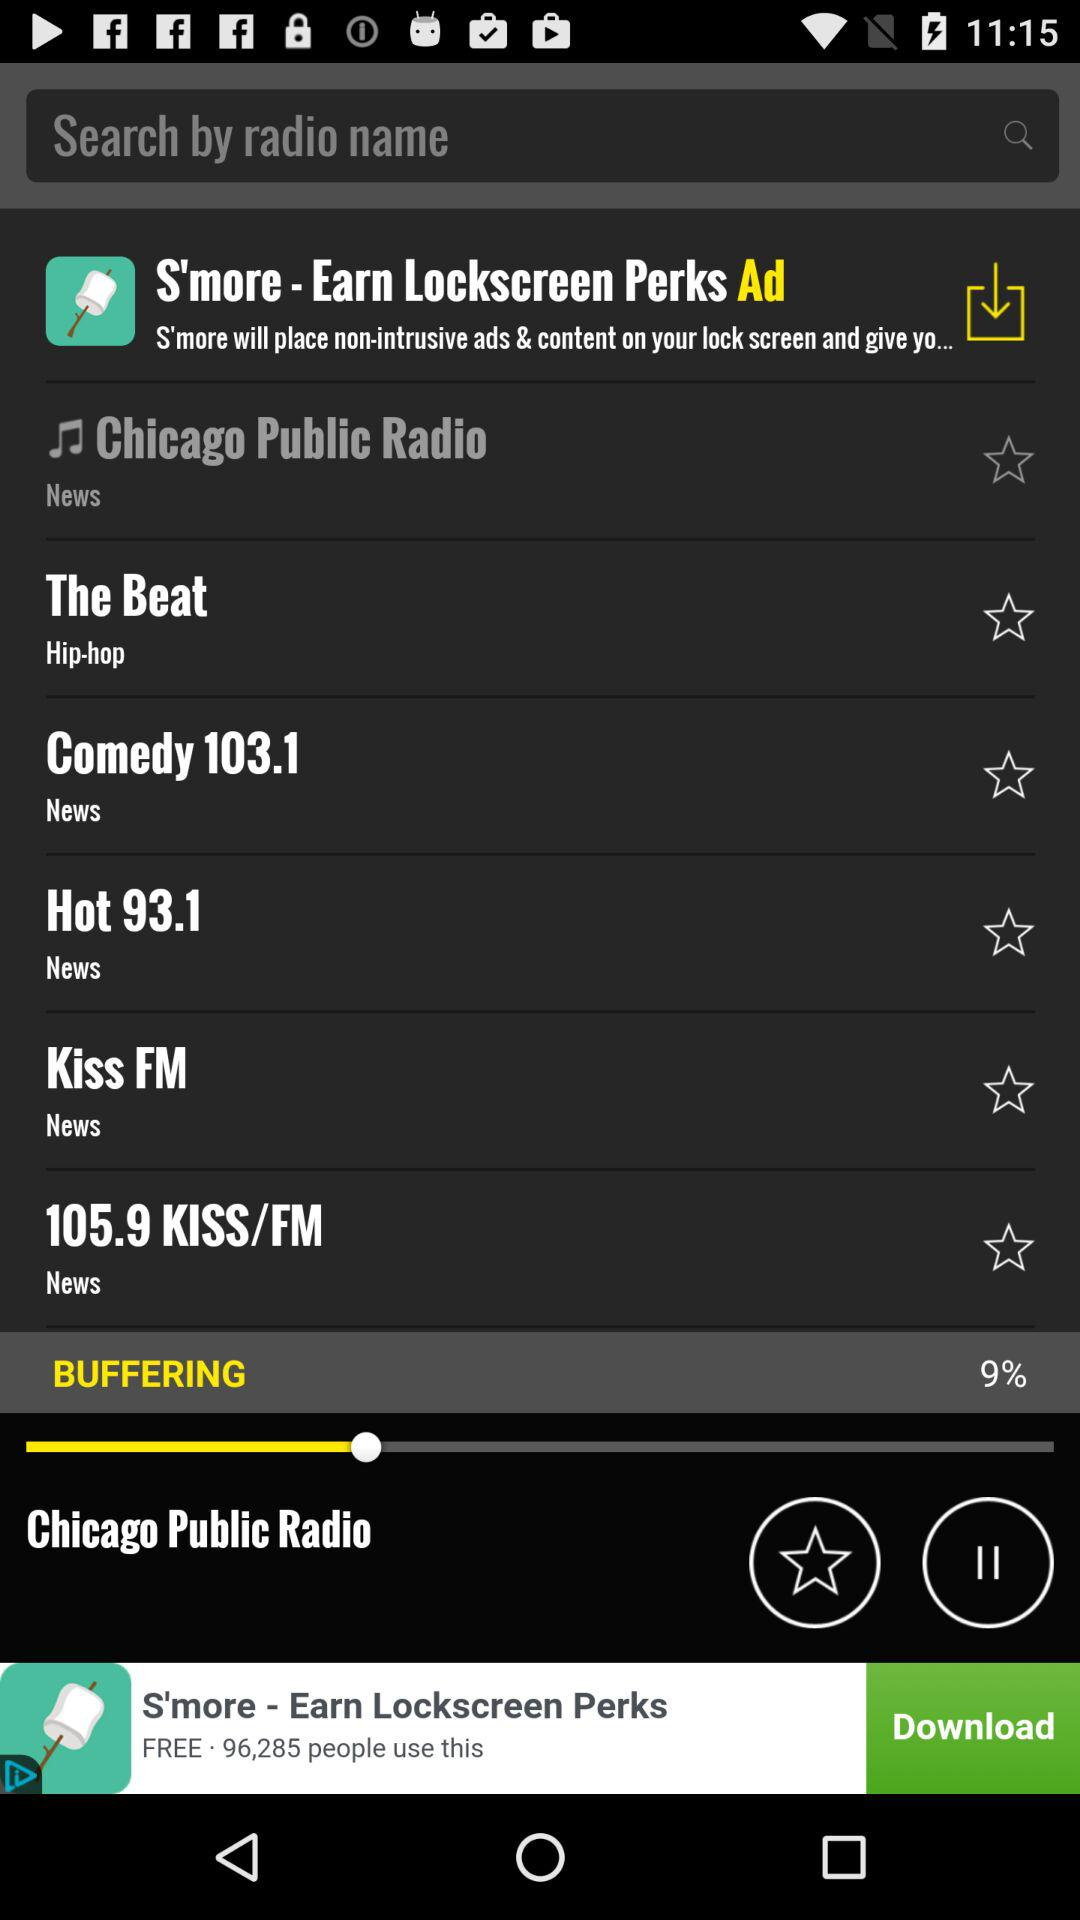What are the available radio channels in the list? The available radio channels in the list are "Chicago Public Radio", "The Beat", "Comedy 103.1", "Hot 93.1", "Kiss FM" and "105.9 KISS/FM". 